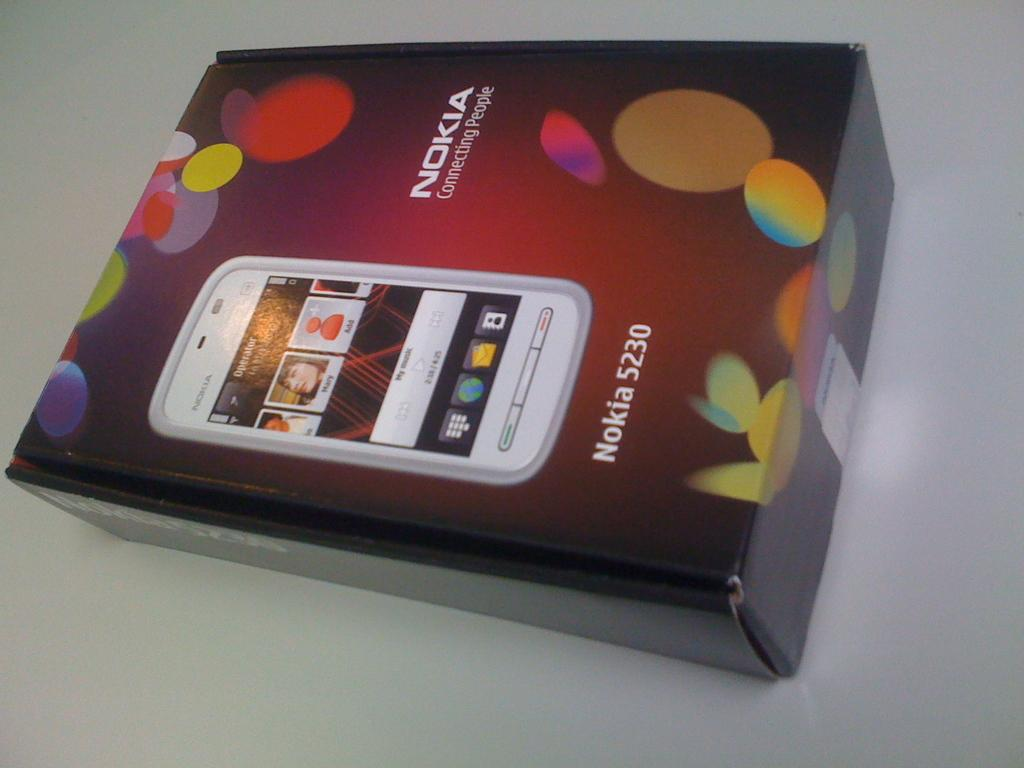<image>
Give a short and clear explanation of the subsequent image. A box for Nokia 5230 miobile phone has a picture of the phone on it. 